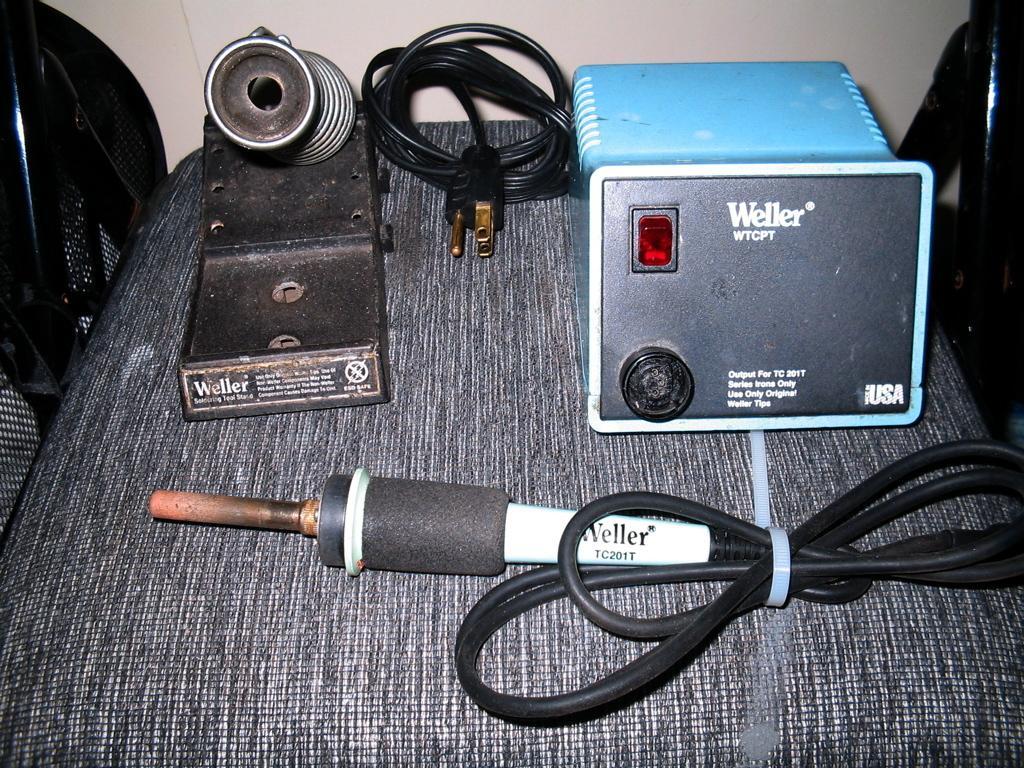Could you give a brief overview of what you see in this image? In this image, we can see a table, on that table there is a black and blue color object, there is an electric object on the table, there is a black color cable on the table. 